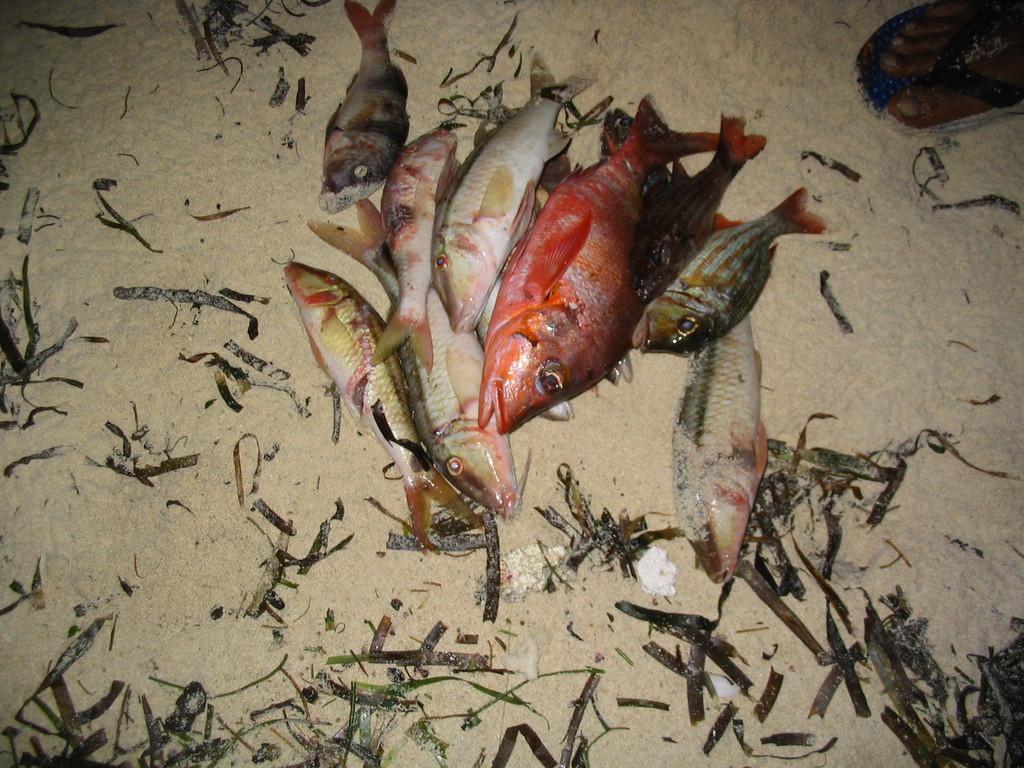In one or two sentences, can you explain what this image depicts? In this image I can see few fish and few leaves on the ground. To the top right corner of the image I can see a human leg. 